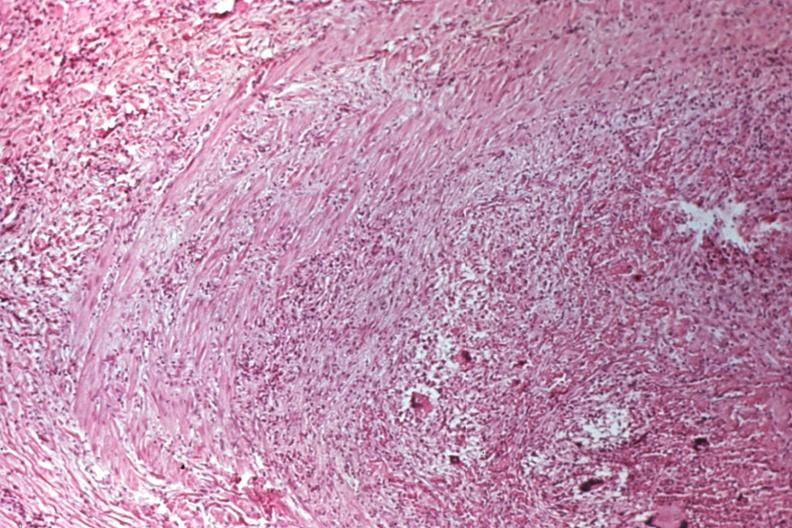does linear fracture in occiput show migratory thrombophlebitis?
Answer the question using a single word or phrase. No 